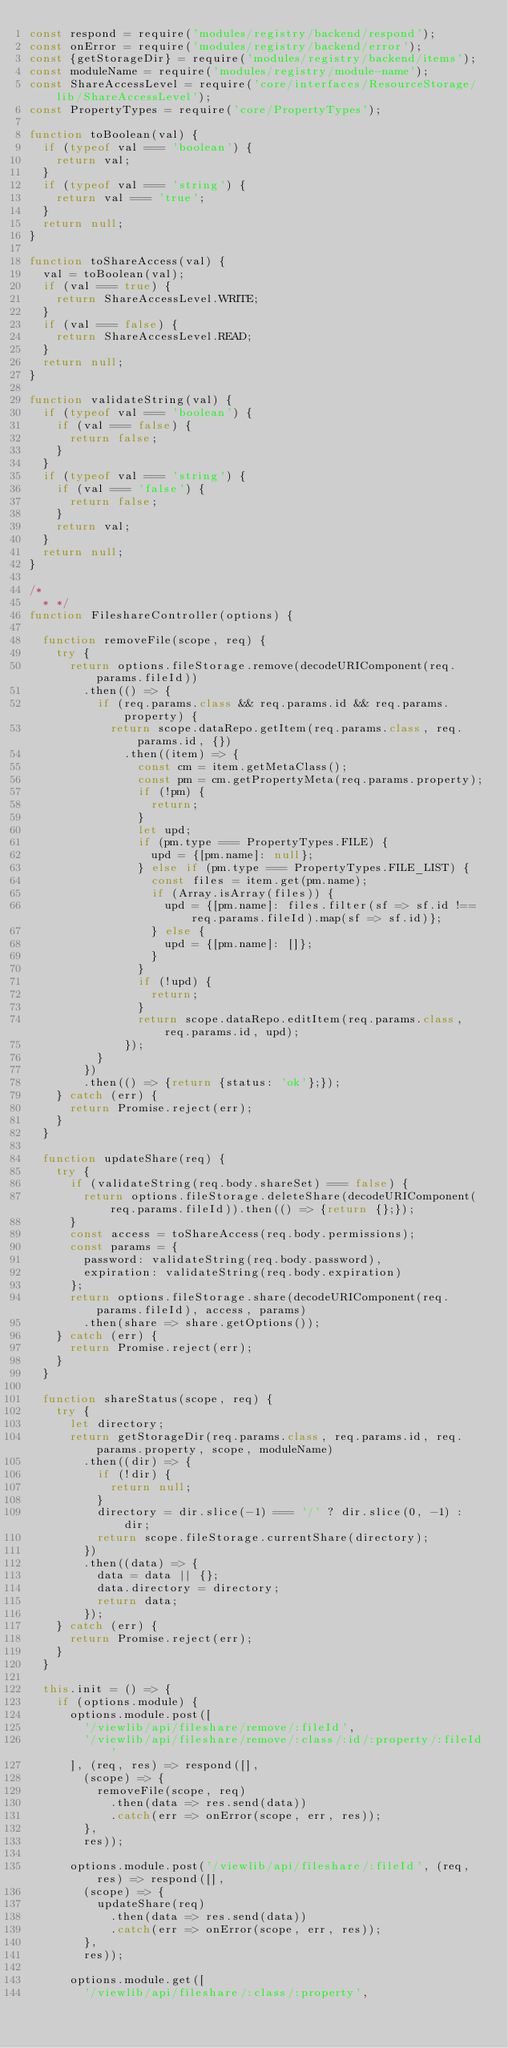<code> <loc_0><loc_0><loc_500><loc_500><_JavaScript_>const respond = require('modules/registry/backend/respond');
const onError = require('modules/registry/backend/error');
const {getStorageDir} = require('modules/registry/backend/items');
const moduleName = require('modules/registry/module-name');
const ShareAccessLevel = require('core/interfaces/ResourceStorage/lib/ShareAccessLevel');
const PropertyTypes = require('core/PropertyTypes');

function toBoolean(val) {
  if (typeof val === 'boolean') {
    return val;
  }
  if (typeof val === 'string') {
    return val === 'true';
  }
  return null;
}

function toShareAccess(val) {
  val = toBoolean(val);
  if (val === true) {
    return ShareAccessLevel.WRITE;
  }
  if (val === false) {
    return ShareAccessLevel.READ;
  }
  return null;
}

function validateString(val) {
  if (typeof val === 'boolean') {
    if (val === false) {
      return false;
    }
  }
  if (typeof val === 'string') {
    if (val === 'false') {
      return false;
    }
    return val;
  }
  return null;
}

/*
  * */
function FileshareController(options) {

  function removeFile(scope, req) {
    try {
      return options.fileStorage.remove(decodeURIComponent(req.params.fileId))
        .then(() => {
          if (req.params.class && req.params.id && req.params.property) {
            return scope.dataRepo.getItem(req.params.class, req.params.id, {})
              .then((item) => {
                const cm = item.getMetaClass();
                const pm = cm.getPropertyMeta(req.params.property);
                if (!pm) {
                  return;
                }
                let upd;
                if (pm.type === PropertyTypes.FILE) {
                  upd = {[pm.name]: null};
                } else if (pm.type === PropertyTypes.FILE_LIST) {
                  const files = item.get(pm.name);
                  if (Array.isArray(files)) {
                    upd = {[pm.name]: files.filter(sf => sf.id !== req.params.fileId).map(sf => sf.id)};
                  } else {
                    upd = {[pm.name]: []};
                  }
                }
                if (!upd) {
                  return;
                }
                return scope.dataRepo.editItem(req.params.class, req.params.id, upd);
              });
          }
        })
        .then(() => {return {status: 'ok'};});
    } catch (err) {
      return Promise.reject(err);
    }
  }

  function updateShare(req) {
    try {
      if (validateString(req.body.shareSet) === false) {
        return options.fileStorage.deleteShare(decodeURIComponent(req.params.fileId)).then(() => {return {};});
      }
      const access = toShareAccess(req.body.permissions);
      const params = {
        password: validateString(req.body.password),
        expiration: validateString(req.body.expiration)
      };
      return options.fileStorage.share(decodeURIComponent(req.params.fileId), access, params)
        .then(share => share.getOptions());
    } catch (err) {
      return Promise.reject(err);
    }
  }

  function shareStatus(scope, req) {
    try {
      let directory;
      return getStorageDir(req.params.class, req.params.id, req.params.property, scope, moduleName)
        .then((dir) => {
          if (!dir) {
            return null;
          }
          directory = dir.slice(-1) === '/' ? dir.slice(0, -1) : dir;
          return scope.fileStorage.currentShare(directory);
        })
        .then((data) => {
          data = data || {};
          data.directory = directory;
          return data;
        });
    } catch (err) {
      return Promise.reject(err);
    }
  }

  this.init = () => {
    if (options.module) {
      options.module.post([
        '/viewlib/api/fileshare/remove/:fileId',
        '/viewlib/api/fileshare/remove/:class/:id/:property/:fileId'
      ], (req, res) => respond([],
        (scope) => {
          removeFile(scope, req)
            .then(data => res.send(data))
            .catch(err => onError(scope, err, res));
        },
        res));

      options.module.post('/viewlib/api/fileshare/:fileId', (req, res) => respond([],
        (scope) => {
          updateShare(req)
            .then(data => res.send(data))
            .catch(err => onError(scope, err, res));
        },
        res));

      options.module.get([
        '/viewlib/api/fileshare/:class/:property',</code> 